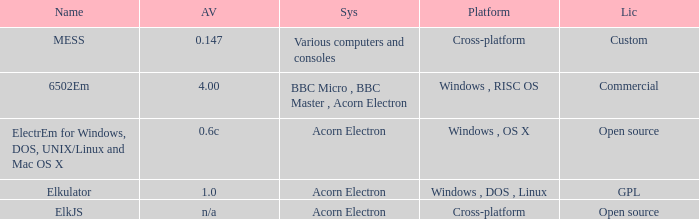What is the arrangement designated as elkjs? Acorn Electron. 